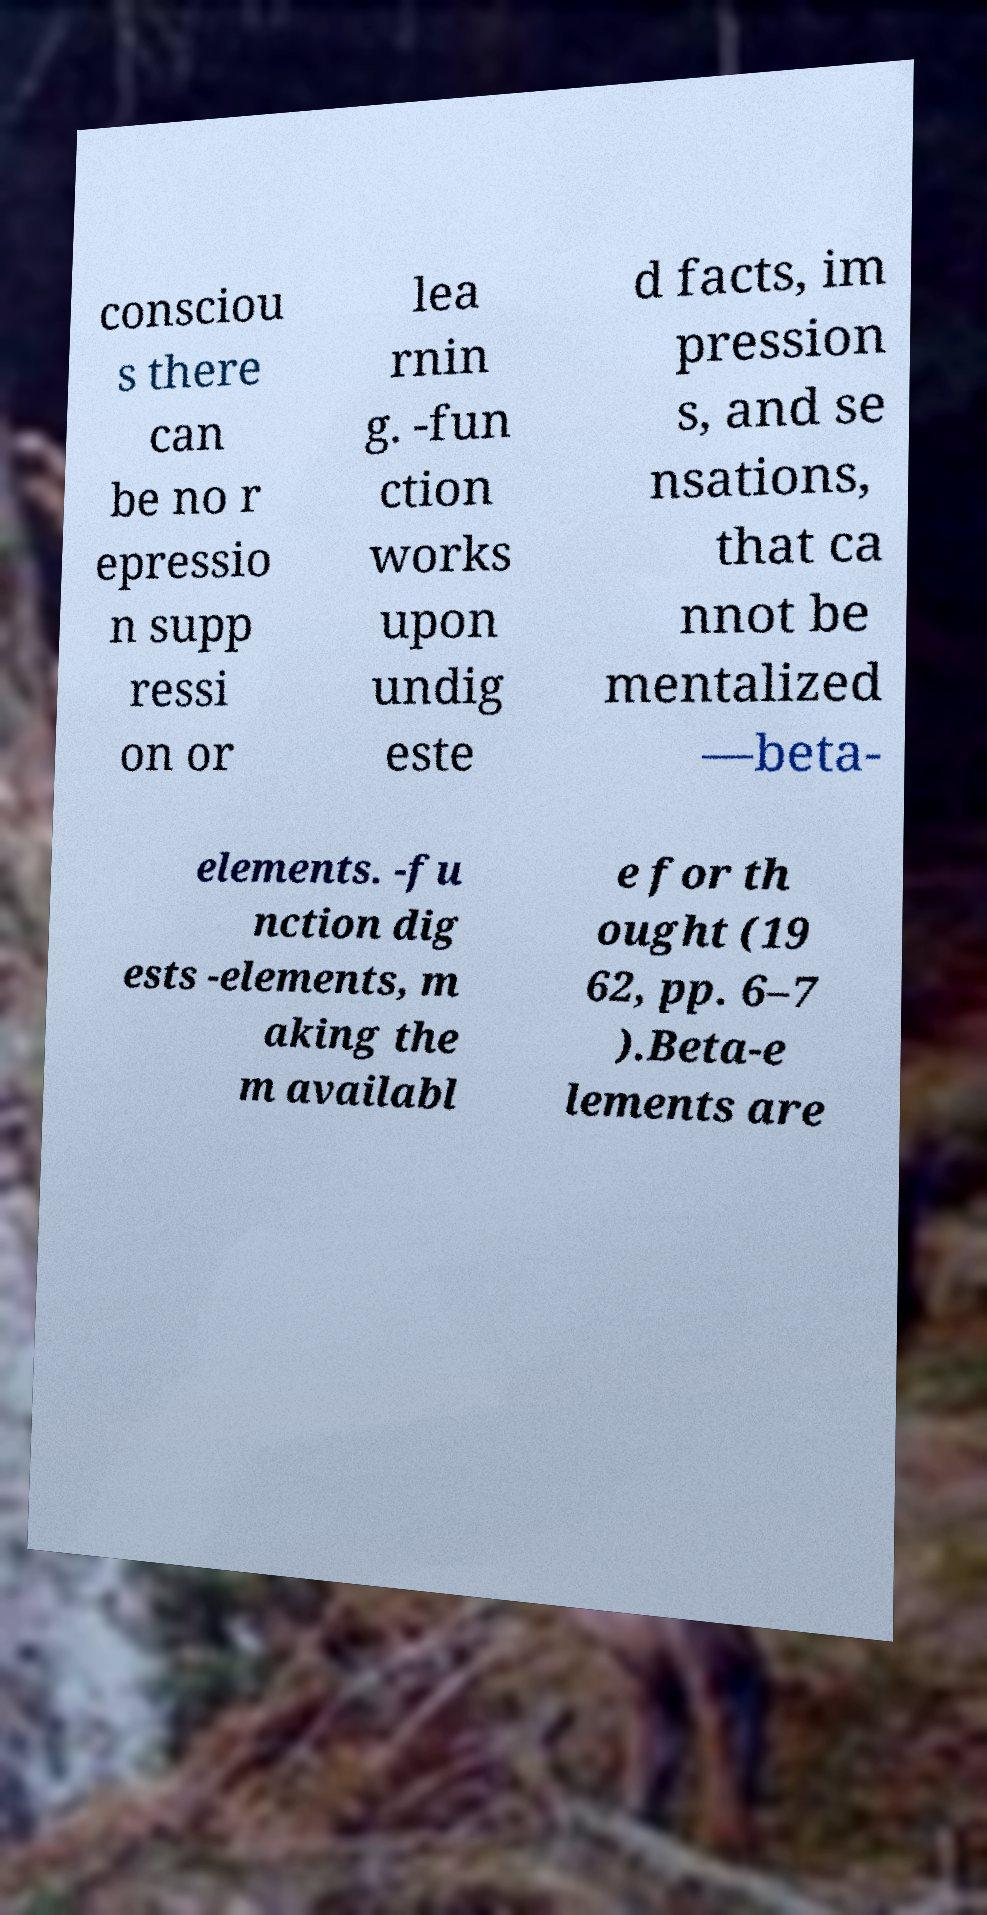Please identify and transcribe the text found in this image. consciou s there can be no r epressio n supp ressi on or lea rnin g. -fun ction works upon undig este d facts, im pression s, and se nsations, that ca nnot be mentalized —beta- elements. -fu nction dig ests -elements, m aking the m availabl e for th ought (19 62, pp. 6–7 ).Beta-e lements are 